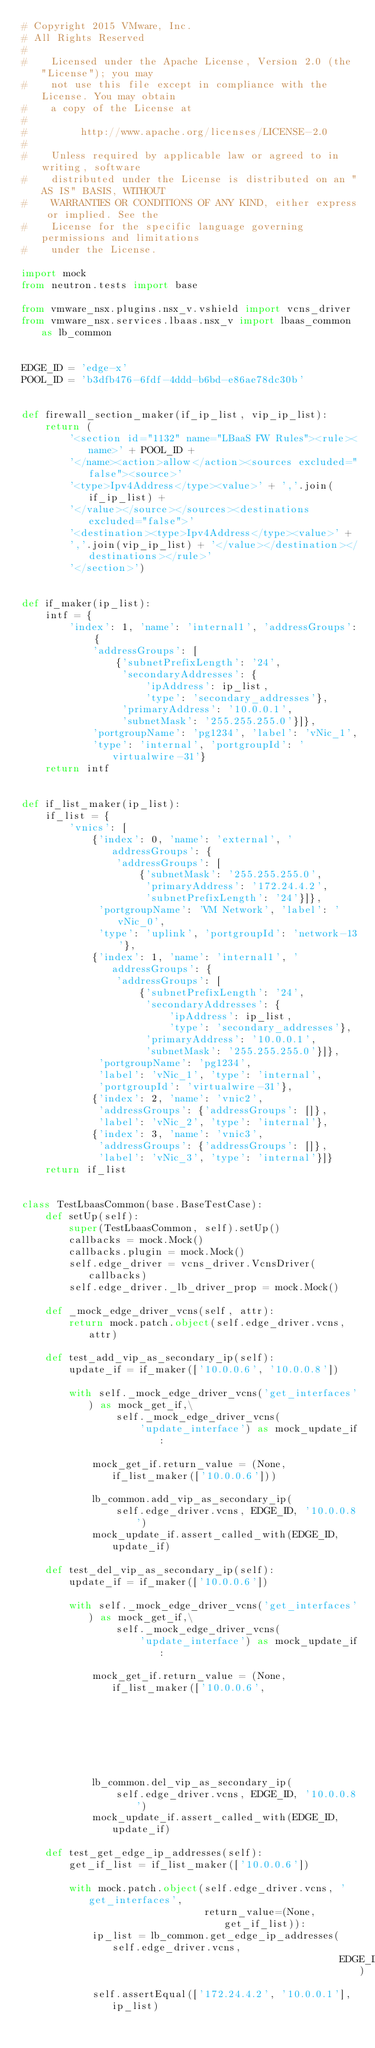Convert code to text. <code><loc_0><loc_0><loc_500><loc_500><_Python_># Copyright 2015 VMware, Inc.
# All Rights Reserved
#
#    Licensed under the Apache License, Version 2.0 (the "License"); you may
#    not use this file except in compliance with the License. You may obtain
#    a copy of the License at
#
#         http://www.apache.org/licenses/LICENSE-2.0
#
#    Unless required by applicable law or agreed to in writing, software
#    distributed under the License is distributed on an "AS IS" BASIS, WITHOUT
#    WARRANTIES OR CONDITIONS OF ANY KIND, either express or implied. See the
#    License for the specific language governing permissions and limitations
#    under the License.

import mock
from neutron.tests import base

from vmware_nsx.plugins.nsx_v.vshield import vcns_driver
from vmware_nsx.services.lbaas.nsx_v import lbaas_common as lb_common


EDGE_ID = 'edge-x'
POOL_ID = 'b3dfb476-6fdf-4ddd-b6bd-e86ae78dc30b'


def firewall_section_maker(if_ip_list, vip_ip_list):
    return (
        '<section id="1132" name="LBaaS FW Rules"><rule><name>' + POOL_ID +
        '</name><action>allow</action><sources excluded="false"><source>'
        '<type>Ipv4Address</type><value>' + ','.join(if_ip_list) +
        '</value></source></sources><destinations excluded="false">'
        '<destination><type>Ipv4Address</type><value>' +
        ','.join(vip_ip_list) + '</value></destination></destinations></rule>'
        '</section>')


def if_maker(ip_list):
    intf = {
        'index': 1, 'name': 'internal1', 'addressGroups': {
            'addressGroups': [
                {'subnetPrefixLength': '24',
                 'secondaryAddresses': {
                     'ipAddress': ip_list,
                     'type': 'secondary_addresses'},
                 'primaryAddress': '10.0.0.1',
                 'subnetMask': '255.255.255.0'}]},
            'portgroupName': 'pg1234', 'label': 'vNic_1',
            'type': 'internal', 'portgroupId': 'virtualwire-31'}
    return intf


def if_list_maker(ip_list):
    if_list = {
        'vnics': [
            {'index': 0, 'name': 'external', 'addressGroups': {
                'addressGroups': [
                    {'subnetMask': '255.255.255.0',
                     'primaryAddress': '172.24.4.2',
                     'subnetPrefixLength': '24'}]},
             'portgroupName': 'VM Network', 'label': 'vNic_0',
             'type': 'uplink', 'portgroupId': 'network-13'},
            {'index': 1, 'name': 'internal1', 'addressGroups': {
                'addressGroups': [
                    {'subnetPrefixLength': '24',
                     'secondaryAddresses': {
                         'ipAddress': ip_list,
                         'type': 'secondary_addresses'},
                     'primaryAddress': '10.0.0.1',
                     'subnetMask': '255.255.255.0'}]},
             'portgroupName': 'pg1234',
             'label': 'vNic_1', 'type': 'internal',
             'portgroupId': 'virtualwire-31'},
            {'index': 2, 'name': 'vnic2',
             'addressGroups': {'addressGroups': []},
             'label': 'vNic_2', 'type': 'internal'},
            {'index': 3, 'name': 'vnic3',
             'addressGroups': {'addressGroups': []},
             'label': 'vNic_3', 'type': 'internal'}]}
    return if_list


class TestLbaasCommon(base.BaseTestCase):
    def setUp(self):
        super(TestLbaasCommon, self).setUp()
        callbacks = mock.Mock()
        callbacks.plugin = mock.Mock()
        self.edge_driver = vcns_driver.VcnsDriver(callbacks)
        self.edge_driver._lb_driver_prop = mock.Mock()

    def _mock_edge_driver_vcns(self, attr):
        return mock.patch.object(self.edge_driver.vcns, attr)

    def test_add_vip_as_secondary_ip(self):
        update_if = if_maker(['10.0.0.6', '10.0.0.8'])

        with self._mock_edge_driver_vcns('get_interfaces') as mock_get_if,\
                self._mock_edge_driver_vcns(
                    'update_interface') as mock_update_if:

            mock_get_if.return_value = (None, if_list_maker(['10.0.0.6']))

            lb_common.add_vip_as_secondary_ip(
                self.edge_driver.vcns, EDGE_ID, '10.0.0.8')
            mock_update_if.assert_called_with(EDGE_ID, update_if)

    def test_del_vip_as_secondary_ip(self):
        update_if = if_maker(['10.0.0.6'])

        with self._mock_edge_driver_vcns('get_interfaces') as mock_get_if,\
                self._mock_edge_driver_vcns(
                    'update_interface') as mock_update_if:

            mock_get_if.return_value = (None, if_list_maker(['10.0.0.6',
                                                             '10.0.0.8']))

            lb_common.del_vip_as_secondary_ip(
                self.edge_driver.vcns, EDGE_ID, '10.0.0.8')
            mock_update_if.assert_called_with(EDGE_ID, update_if)

    def test_get_edge_ip_addresses(self):
        get_if_list = if_list_maker(['10.0.0.6'])

        with mock.patch.object(self.edge_driver.vcns, 'get_interfaces',
                               return_value=(None, get_if_list)):
            ip_list = lb_common.get_edge_ip_addresses(self.edge_driver.vcns,
                                                      EDGE_ID)
            self.assertEqual(['172.24.4.2', '10.0.0.1'], ip_list)
</code> 